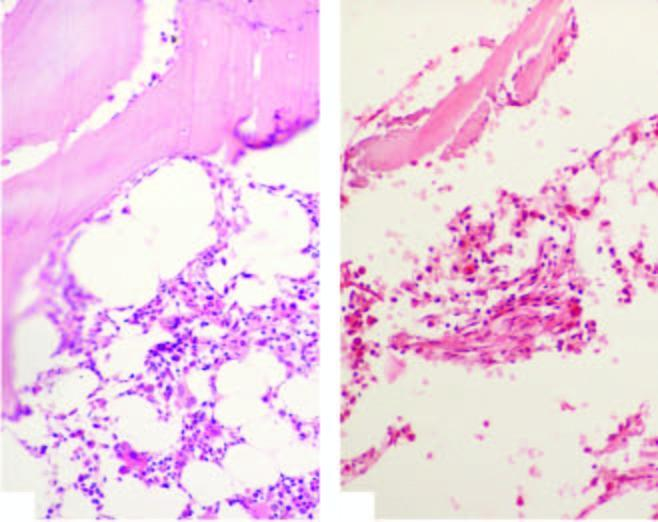how does the biopsy show suppression of myeloid and erythroid cells and replacement of haematopoetic elements in aplastic anaemia?
Answer the question using a single word or phrase. By fat 